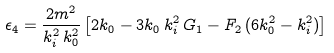Convert formula to latex. <formula><loc_0><loc_0><loc_500><loc_500>\epsilon _ { 4 } = \frac { 2 m ^ { 2 } } { k _ { i } ^ { 2 } \, k _ { 0 } ^ { 2 } } \left [ 2 k _ { 0 } - 3 k _ { 0 } \, k _ { i } ^ { 2 } \, G _ { 1 } - F _ { 2 } \, ( 6 k _ { 0 } ^ { 2 } - k _ { i } ^ { 2 } ) \right ]</formula> 